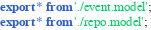Convert code to text. <code><loc_0><loc_0><loc_500><loc_500><_TypeScript_>export * from './event.model';
export * from './repo.model';</code> 